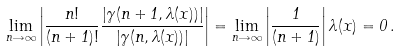<formula> <loc_0><loc_0><loc_500><loc_500>\lim _ { n \rightarrow \infty } \left | \frac { n ! } { ( n + 1 ) ! } \frac { \left | \gamma ( n + 1 , \lambda ( x ) ) \right | } { \left | \gamma ( n , \lambda ( x ) ) \right | } \right | = \lim _ { n \rightarrow \infty } \left | \frac { 1 } { ( n + 1 ) } \right | \lambda ( x ) = 0 \, .</formula> 